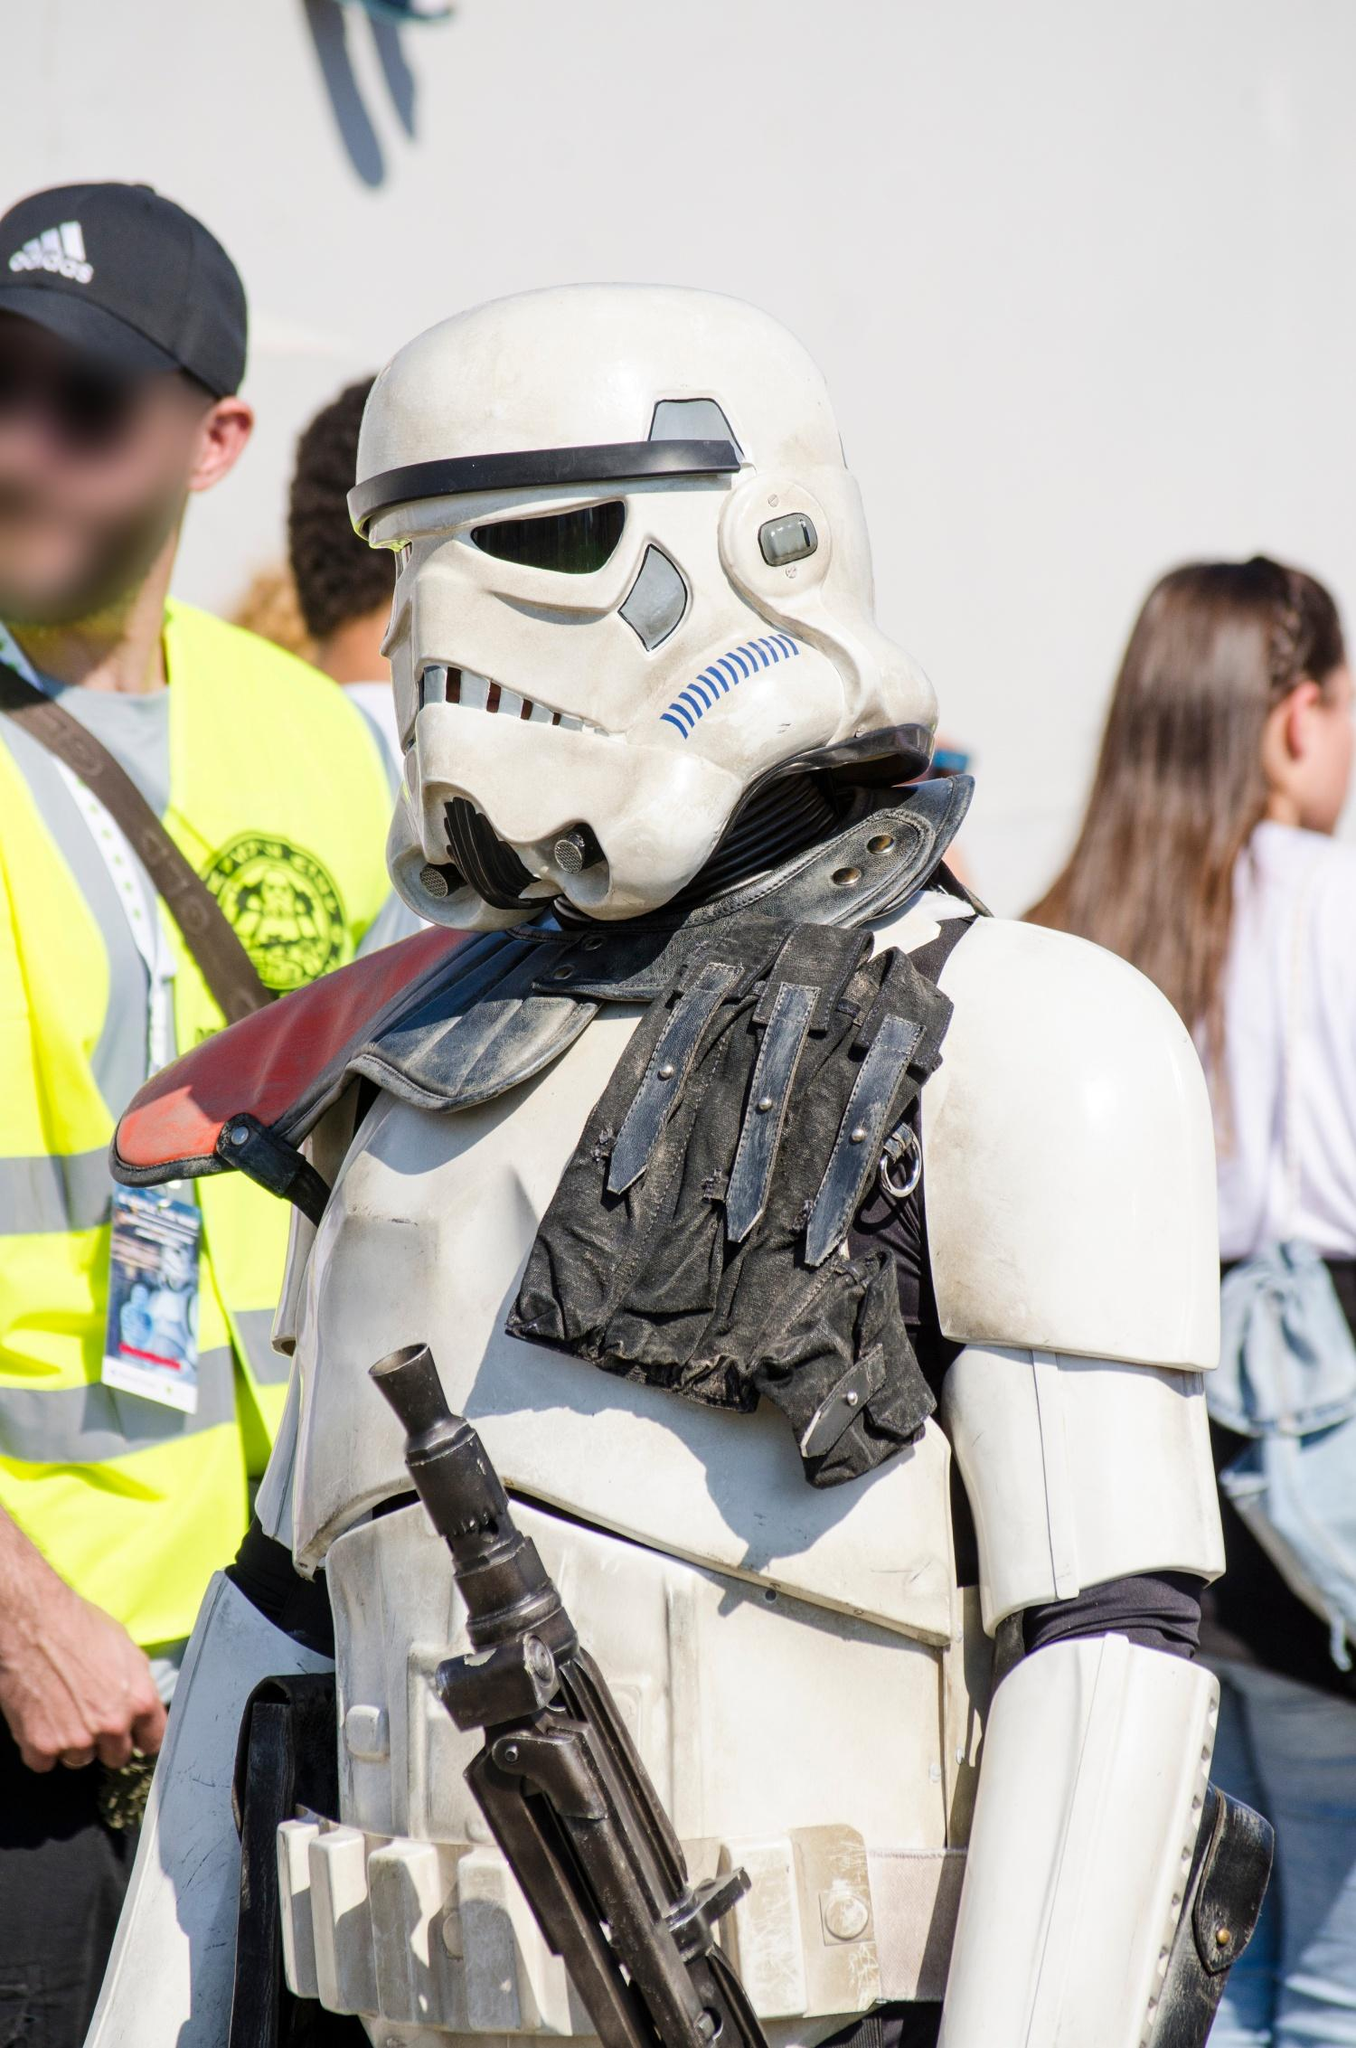Imagine the Stormtrooper in this image is on a mission. Describe the mission and the setting in a detailed story. The Stormtrooper in the image, let's call him TK-421, has been assigned a critical mission by the Galactic Empire. His orders are to infiltrate a bustling spaceport city on the planet Coruscant, disguised amongst the galactic citizens. The city is a hive of activity, with towering skyscrapers, neon signs, and flying vehicles crisscrossing the skyline. TK-421 must navigate through the crowded streets, keeping a low profile while gathering intelligence on a suspected Rebel cell operating in the area.

Under the cover of the city’s vibrant nightlife, he moves through the crowds, his blaster concealed within the folds of his armor. He exchanges coded communications with Imperial spies embedded within the local populace. In the heart of the spaceport, hidden in an abandoned warehouse, TK-421 uncovers a secret Rebel base. The base is filled with hastily constructed technology and equipment, evidence of the Rebel's planning a significant operation.

TK-421 alerts his superiors, providing detailed coordinates and descriptions of the Rebel activities. As dawn breaks, Imperial forces descend upon the warehouse, catching the Rebels off guard. The mission ends successfully with the dismantling of the Rebel cell, a testament to TK-421’s skills and dedication to the Empire. 